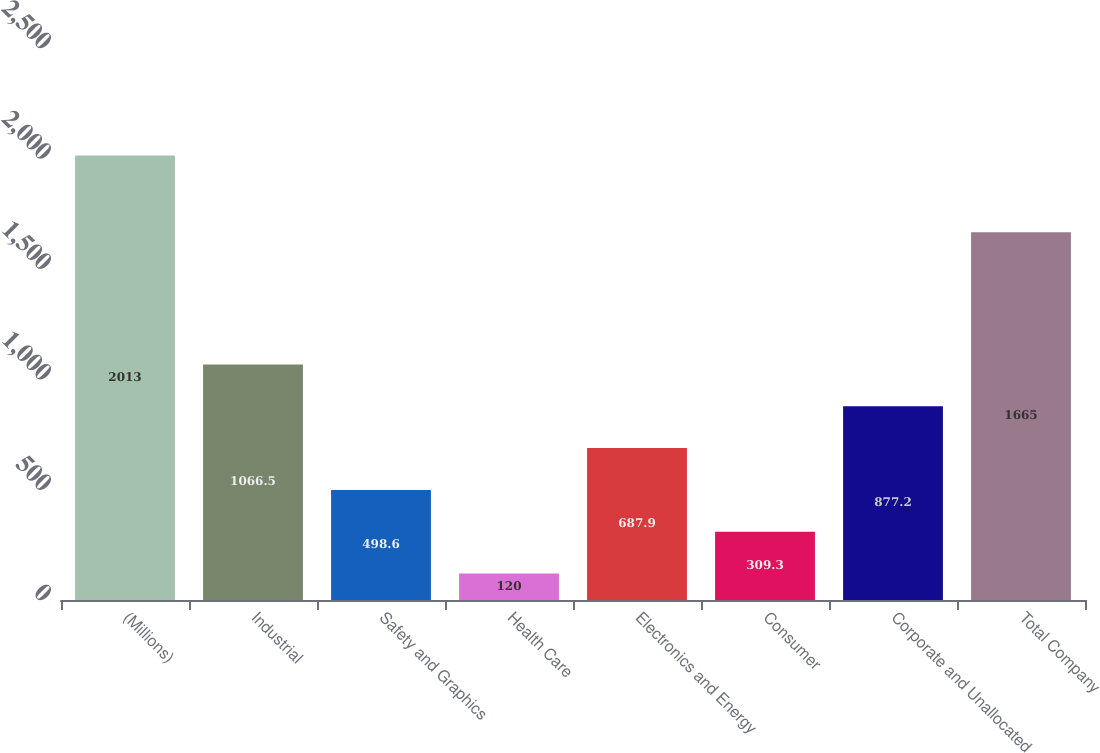Convert chart to OTSL. <chart><loc_0><loc_0><loc_500><loc_500><bar_chart><fcel>(Millions)<fcel>Industrial<fcel>Safety and Graphics<fcel>Health Care<fcel>Electronics and Energy<fcel>Consumer<fcel>Corporate and Unallocated<fcel>Total Company<nl><fcel>2013<fcel>1066.5<fcel>498.6<fcel>120<fcel>687.9<fcel>309.3<fcel>877.2<fcel>1665<nl></chart> 